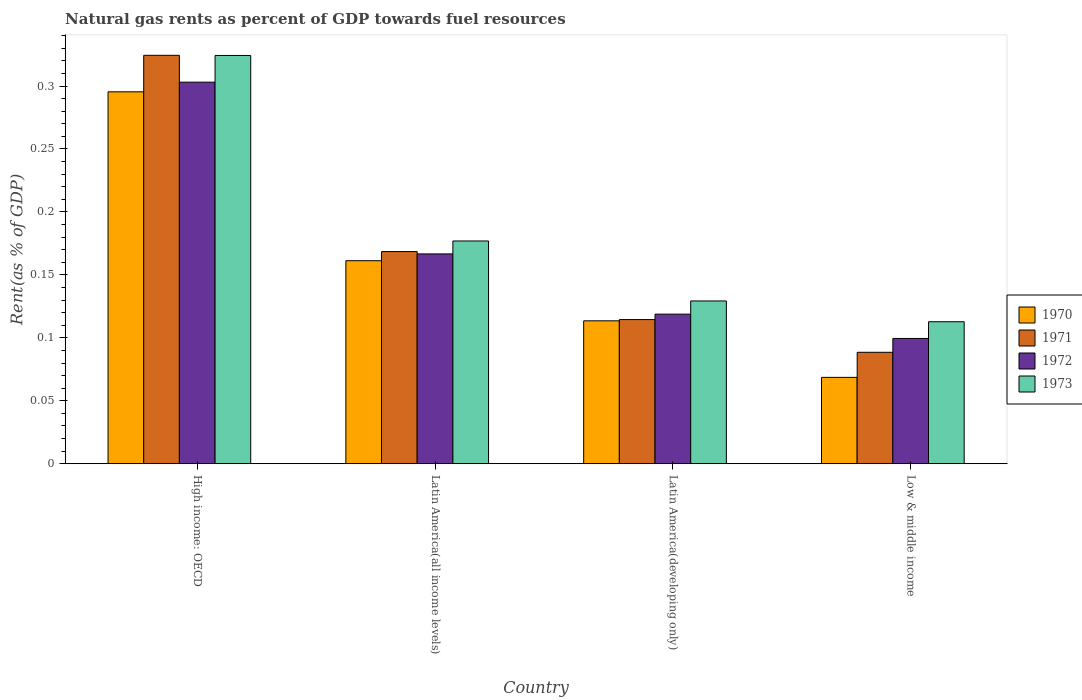Are the number of bars per tick equal to the number of legend labels?
Provide a short and direct response. Yes. How many bars are there on the 2nd tick from the right?
Provide a short and direct response. 4. What is the label of the 4th group of bars from the left?
Ensure brevity in your answer.  Low & middle income. What is the matural gas rent in 1972 in High income: OECD?
Make the answer very short. 0.3. Across all countries, what is the maximum matural gas rent in 1970?
Offer a terse response. 0.3. Across all countries, what is the minimum matural gas rent in 1970?
Provide a short and direct response. 0.07. In which country was the matural gas rent in 1971 maximum?
Give a very brief answer. High income: OECD. What is the total matural gas rent in 1972 in the graph?
Ensure brevity in your answer.  0.69. What is the difference between the matural gas rent in 1971 in Latin America(all income levels) and that in Low & middle income?
Your answer should be very brief. 0.08. What is the difference between the matural gas rent in 1973 in Latin America(developing only) and the matural gas rent in 1971 in High income: OECD?
Your answer should be compact. -0.2. What is the average matural gas rent in 1971 per country?
Provide a short and direct response. 0.17. What is the difference between the matural gas rent of/in 1970 and matural gas rent of/in 1973 in Low & middle income?
Give a very brief answer. -0.04. What is the ratio of the matural gas rent in 1973 in High income: OECD to that in Latin America(all income levels)?
Provide a short and direct response. 1.83. Is the matural gas rent in 1971 in High income: OECD less than that in Latin America(developing only)?
Ensure brevity in your answer.  No. Is the difference between the matural gas rent in 1970 in High income: OECD and Low & middle income greater than the difference between the matural gas rent in 1973 in High income: OECD and Low & middle income?
Your answer should be very brief. Yes. What is the difference between the highest and the second highest matural gas rent in 1970?
Offer a very short reply. 0.13. What is the difference between the highest and the lowest matural gas rent in 1971?
Offer a very short reply. 0.24. In how many countries, is the matural gas rent in 1973 greater than the average matural gas rent in 1973 taken over all countries?
Offer a terse response. 1. Is it the case that in every country, the sum of the matural gas rent in 1971 and matural gas rent in 1972 is greater than the sum of matural gas rent in 1973 and matural gas rent in 1970?
Offer a very short reply. No. Is it the case that in every country, the sum of the matural gas rent in 1973 and matural gas rent in 1971 is greater than the matural gas rent in 1972?
Your answer should be compact. Yes. What is the difference between two consecutive major ticks on the Y-axis?
Your answer should be compact. 0.05. Are the values on the major ticks of Y-axis written in scientific E-notation?
Give a very brief answer. No. Does the graph contain grids?
Keep it short and to the point. No. What is the title of the graph?
Offer a very short reply. Natural gas rents as percent of GDP towards fuel resources. Does "1977" appear as one of the legend labels in the graph?
Your answer should be very brief. No. What is the label or title of the X-axis?
Offer a very short reply. Country. What is the label or title of the Y-axis?
Offer a terse response. Rent(as % of GDP). What is the Rent(as % of GDP) of 1970 in High income: OECD?
Keep it short and to the point. 0.3. What is the Rent(as % of GDP) of 1971 in High income: OECD?
Provide a succinct answer. 0.32. What is the Rent(as % of GDP) in 1972 in High income: OECD?
Ensure brevity in your answer.  0.3. What is the Rent(as % of GDP) in 1973 in High income: OECD?
Your response must be concise. 0.32. What is the Rent(as % of GDP) of 1970 in Latin America(all income levels)?
Offer a terse response. 0.16. What is the Rent(as % of GDP) of 1971 in Latin America(all income levels)?
Your answer should be compact. 0.17. What is the Rent(as % of GDP) of 1972 in Latin America(all income levels)?
Your answer should be compact. 0.17. What is the Rent(as % of GDP) of 1973 in Latin America(all income levels)?
Offer a very short reply. 0.18. What is the Rent(as % of GDP) of 1970 in Latin America(developing only)?
Keep it short and to the point. 0.11. What is the Rent(as % of GDP) in 1971 in Latin America(developing only)?
Offer a terse response. 0.11. What is the Rent(as % of GDP) of 1972 in Latin America(developing only)?
Your answer should be compact. 0.12. What is the Rent(as % of GDP) of 1973 in Latin America(developing only)?
Keep it short and to the point. 0.13. What is the Rent(as % of GDP) in 1970 in Low & middle income?
Keep it short and to the point. 0.07. What is the Rent(as % of GDP) of 1971 in Low & middle income?
Provide a succinct answer. 0.09. What is the Rent(as % of GDP) in 1972 in Low & middle income?
Offer a very short reply. 0.1. What is the Rent(as % of GDP) in 1973 in Low & middle income?
Offer a terse response. 0.11. Across all countries, what is the maximum Rent(as % of GDP) of 1970?
Give a very brief answer. 0.3. Across all countries, what is the maximum Rent(as % of GDP) of 1971?
Your answer should be compact. 0.32. Across all countries, what is the maximum Rent(as % of GDP) in 1972?
Offer a very short reply. 0.3. Across all countries, what is the maximum Rent(as % of GDP) in 1973?
Offer a very short reply. 0.32. Across all countries, what is the minimum Rent(as % of GDP) of 1970?
Keep it short and to the point. 0.07. Across all countries, what is the minimum Rent(as % of GDP) in 1971?
Offer a very short reply. 0.09. Across all countries, what is the minimum Rent(as % of GDP) in 1972?
Your response must be concise. 0.1. Across all countries, what is the minimum Rent(as % of GDP) in 1973?
Provide a succinct answer. 0.11. What is the total Rent(as % of GDP) in 1970 in the graph?
Provide a succinct answer. 0.64. What is the total Rent(as % of GDP) of 1971 in the graph?
Provide a short and direct response. 0.7. What is the total Rent(as % of GDP) of 1972 in the graph?
Give a very brief answer. 0.69. What is the total Rent(as % of GDP) of 1973 in the graph?
Your answer should be very brief. 0.74. What is the difference between the Rent(as % of GDP) of 1970 in High income: OECD and that in Latin America(all income levels)?
Your response must be concise. 0.13. What is the difference between the Rent(as % of GDP) in 1971 in High income: OECD and that in Latin America(all income levels)?
Make the answer very short. 0.16. What is the difference between the Rent(as % of GDP) in 1972 in High income: OECD and that in Latin America(all income levels)?
Your answer should be compact. 0.14. What is the difference between the Rent(as % of GDP) of 1973 in High income: OECD and that in Latin America(all income levels)?
Offer a terse response. 0.15. What is the difference between the Rent(as % of GDP) of 1970 in High income: OECD and that in Latin America(developing only)?
Make the answer very short. 0.18. What is the difference between the Rent(as % of GDP) in 1971 in High income: OECD and that in Latin America(developing only)?
Your answer should be very brief. 0.21. What is the difference between the Rent(as % of GDP) in 1972 in High income: OECD and that in Latin America(developing only)?
Offer a very short reply. 0.18. What is the difference between the Rent(as % of GDP) of 1973 in High income: OECD and that in Latin America(developing only)?
Your answer should be compact. 0.2. What is the difference between the Rent(as % of GDP) in 1970 in High income: OECD and that in Low & middle income?
Keep it short and to the point. 0.23. What is the difference between the Rent(as % of GDP) of 1971 in High income: OECD and that in Low & middle income?
Ensure brevity in your answer.  0.24. What is the difference between the Rent(as % of GDP) in 1972 in High income: OECD and that in Low & middle income?
Your response must be concise. 0.2. What is the difference between the Rent(as % of GDP) in 1973 in High income: OECD and that in Low & middle income?
Your answer should be compact. 0.21. What is the difference between the Rent(as % of GDP) of 1970 in Latin America(all income levels) and that in Latin America(developing only)?
Provide a succinct answer. 0.05. What is the difference between the Rent(as % of GDP) in 1971 in Latin America(all income levels) and that in Latin America(developing only)?
Your response must be concise. 0.05. What is the difference between the Rent(as % of GDP) in 1972 in Latin America(all income levels) and that in Latin America(developing only)?
Offer a very short reply. 0.05. What is the difference between the Rent(as % of GDP) in 1973 in Latin America(all income levels) and that in Latin America(developing only)?
Your response must be concise. 0.05. What is the difference between the Rent(as % of GDP) in 1970 in Latin America(all income levels) and that in Low & middle income?
Provide a short and direct response. 0.09. What is the difference between the Rent(as % of GDP) of 1971 in Latin America(all income levels) and that in Low & middle income?
Keep it short and to the point. 0.08. What is the difference between the Rent(as % of GDP) in 1972 in Latin America(all income levels) and that in Low & middle income?
Your response must be concise. 0.07. What is the difference between the Rent(as % of GDP) of 1973 in Latin America(all income levels) and that in Low & middle income?
Make the answer very short. 0.06. What is the difference between the Rent(as % of GDP) in 1970 in Latin America(developing only) and that in Low & middle income?
Ensure brevity in your answer.  0.04. What is the difference between the Rent(as % of GDP) in 1971 in Latin America(developing only) and that in Low & middle income?
Give a very brief answer. 0.03. What is the difference between the Rent(as % of GDP) in 1972 in Latin America(developing only) and that in Low & middle income?
Give a very brief answer. 0.02. What is the difference between the Rent(as % of GDP) in 1973 in Latin America(developing only) and that in Low & middle income?
Offer a terse response. 0.02. What is the difference between the Rent(as % of GDP) in 1970 in High income: OECD and the Rent(as % of GDP) in 1971 in Latin America(all income levels)?
Provide a succinct answer. 0.13. What is the difference between the Rent(as % of GDP) in 1970 in High income: OECD and the Rent(as % of GDP) in 1972 in Latin America(all income levels)?
Offer a terse response. 0.13. What is the difference between the Rent(as % of GDP) of 1970 in High income: OECD and the Rent(as % of GDP) of 1973 in Latin America(all income levels)?
Offer a terse response. 0.12. What is the difference between the Rent(as % of GDP) in 1971 in High income: OECD and the Rent(as % of GDP) in 1972 in Latin America(all income levels)?
Give a very brief answer. 0.16. What is the difference between the Rent(as % of GDP) of 1971 in High income: OECD and the Rent(as % of GDP) of 1973 in Latin America(all income levels)?
Offer a very short reply. 0.15. What is the difference between the Rent(as % of GDP) of 1972 in High income: OECD and the Rent(as % of GDP) of 1973 in Latin America(all income levels)?
Provide a succinct answer. 0.13. What is the difference between the Rent(as % of GDP) of 1970 in High income: OECD and the Rent(as % of GDP) of 1971 in Latin America(developing only)?
Ensure brevity in your answer.  0.18. What is the difference between the Rent(as % of GDP) of 1970 in High income: OECD and the Rent(as % of GDP) of 1972 in Latin America(developing only)?
Provide a succinct answer. 0.18. What is the difference between the Rent(as % of GDP) in 1970 in High income: OECD and the Rent(as % of GDP) in 1973 in Latin America(developing only)?
Your answer should be compact. 0.17. What is the difference between the Rent(as % of GDP) of 1971 in High income: OECD and the Rent(as % of GDP) of 1972 in Latin America(developing only)?
Keep it short and to the point. 0.21. What is the difference between the Rent(as % of GDP) in 1971 in High income: OECD and the Rent(as % of GDP) in 1973 in Latin America(developing only)?
Make the answer very short. 0.2. What is the difference between the Rent(as % of GDP) of 1972 in High income: OECD and the Rent(as % of GDP) of 1973 in Latin America(developing only)?
Ensure brevity in your answer.  0.17. What is the difference between the Rent(as % of GDP) in 1970 in High income: OECD and the Rent(as % of GDP) in 1971 in Low & middle income?
Give a very brief answer. 0.21. What is the difference between the Rent(as % of GDP) in 1970 in High income: OECD and the Rent(as % of GDP) in 1972 in Low & middle income?
Ensure brevity in your answer.  0.2. What is the difference between the Rent(as % of GDP) of 1970 in High income: OECD and the Rent(as % of GDP) of 1973 in Low & middle income?
Your answer should be very brief. 0.18. What is the difference between the Rent(as % of GDP) in 1971 in High income: OECD and the Rent(as % of GDP) in 1972 in Low & middle income?
Keep it short and to the point. 0.22. What is the difference between the Rent(as % of GDP) in 1971 in High income: OECD and the Rent(as % of GDP) in 1973 in Low & middle income?
Your answer should be very brief. 0.21. What is the difference between the Rent(as % of GDP) in 1972 in High income: OECD and the Rent(as % of GDP) in 1973 in Low & middle income?
Your answer should be very brief. 0.19. What is the difference between the Rent(as % of GDP) of 1970 in Latin America(all income levels) and the Rent(as % of GDP) of 1971 in Latin America(developing only)?
Ensure brevity in your answer.  0.05. What is the difference between the Rent(as % of GDP) of 1970 in Latin America(all income levels) and the Rent(as % of GDP) of 1972 in Latin America(developing only)?
Ensure brevity in your answer.  0.04. What is the difference between the Rent(as % of GDP) in 1970 in Latin America(all income levels) and the Rent(as % of GDP) in 1973 in Latin America(developing only)?
Ensure brevity in your answer.  0.03. What is the difference between the Rent(as % of GDP) in 1971 in Latin America(all income levels) and the Rent(as % of GDP) in 1972 in Latin America(developing only)?
Keep it short and to the point. 0.05. What is the difference between the Rent(as % of GDP) in 1971 in Latin America(all income levels) and the Rent(as % of GDP) in 1973 in Latin America(developing only)?
Your answer should be compact. 0.04. What is the difference between the Rent(as % of GDP) of 1972 in Latin America(all income levels) and the Rent(as % of GDP) of 1973 in Latin America(developing only)?
Offer a very short reply. 0.04. What is the difference between the Rent(as % of GDP) of 1970 in Latin America(all income levels) and the Rent(as % of GDP) of 1971 in Low & middle income?
Your answer should be very brief. 0.07. What is the difference between the Rent(as % of GDP) of 1970 in Latin America(all income levels) and the Rent(as % of GDP) of 1972 in Low & middle income?
Offer a very short reply. 0.06. What is the difference between the Rent(as % of GDP) of 1970 in Latin America(all income levels) and the Rent(as % of GDP) of 1973 in Low & middle income?
Offer a terse response. 0.05. What is the difference between the Rent(as % of GDP) in 1971 in Latin America(all income levels) and the Rent(as % of GDP) in 1972 in Low & middle income?
Offer a very short reply. 0.07. What is the difference between the Rent(as % of GDP) of 1971 in Latin America(all income levels) and the Rent(as % of GDP) of 1973 in Low & middle income?
Provide a succinct answer. 0.06. What is the difference between the Rent(as % of GDP) in 1972 in Latin America(all income levels) and the Rent(as % of GDP) in 1973 in Low & middle income?
Offer a terse response. 0.05. What is the difference between the Rent(as % of GDP) in 1970 in Latin America(developing only) and the Rent(as % of GDP) in 1971 in Low & middle income?
Offer a terse response. 0.03. What is the difference between the Rent(as % of GDP) in 1970 in Latin America(developing only) and the Rent(as % of GDP) in 1972 in Low & middle income?
Keep it short and to the point. 0.01. What is the difference between the Rent(as % of GDP) in 1970 in Latin America(developing only) and the Rent(as % of GDP) in 1973 in Low & middle income?
Provide a succinct answer. 0. What is the difference between the Rent(as % of GDP) in 1971 in Latin America(developing only) and the Rent(as % of GDP) in 1972 in Low & middle income?
Provide a short and direct response. 0.01. What is the difference between the Rent(as % of GDP) of 1971 in Latin America(developing only) and the Rent(as % of GDP) of 1973 in Low & middle income?
Offer a terse response. 0. What is the difference between the Rent(as % of GDP) of 1972 in Latin America(developing only) and the Rent(as % of GDP) of 1973 in Low & middle income?
Ensure brevity in your answer.  0.01. What is the average Rent(as % of GDP) in 1970 per country?
Make the answer very short. 0.16. What is the average Rent(as % of GDP) in 1971 per country?
Offer a terse response. 0.17. What is the average Rent(as % of GDP) of 1972 per country?
Make the answer very short. 0.17. What is the average Rent(as % of GDP) in 1973 per country?
Provide a succinct answer. 0.19. What is the difference between the Rent(as % of GDP) in 1970 and Rent(as % of GDP) in 1971 in High income: OECD?
Provide a short and direct response. -0.03. What is the difference between the Rent(as % of GDP) of 1970 and Rent(as % of GDP) of 1972 in High income: OECD?
Give a very brief answer. -0.01. What is the difference between the Rent(as % of GDP) in 1970 and Rent(as % of GDP) in 1973 in High income: OECD?
Provide a succinct answer. -0.03. What is the difference between the Rent(as % of GDP) in 1971 and Rent(as % of GDP) in 1972 in High income: OECD?
Provide a short and direct response. 0.02. What is the difference between the Rent(as % of GDP) of 1971 and Rent(as % of GDP) of 1973 in High income: OECD?
Your answer should be very brief. 0. What is the difference between the Rent(as % of GDP) in 1972 and Rent(as % of GDP) in 1973 in High income: OECD?
Offer a very short reply. -0.02. What is the difference between the Rent(as % of GDP) of 1970 and Rent(as % of GDP) of 1971 in Latin America(all income levels)?
Make the answer very short. -0.01. What is the difference between the Rent(as % of GDP) of 1970 and Rent(as % of GDP) of 1972 in Latin America(all income levels)?
Ensure brevity in your answer.  -0.01. What is the difference between the Rent(as % of GDP) of 1970 and Rent(as % of GDP) of 1973 in Latin America(all income levels)?
Offer a terse response. -0.02. What is the difference between the Rent(as % of GDP) of 1971 and Rent(as % of GDP) of 1972 in Latin America(all income levels)?
Provide a succinct answer. 0. What is the difference between the Rent(as % of GDP) of 1971 and Rent(as % of GDP) of 1973 in Latin America(all income levels)?
Give a very brief answer. -0.01. What is the difference between the Rent(as % of GDP) in 1972 and Rent(as % of GDP) in 1973 in Latin America(all income levels)?
Keep it short and to the point. -0.01. What is the difference between the Rent(as % of GDP) in 1970 and Rent(as % of GDP) in 1971 in Latin America(developing only)?
Offer a terse response. -0. What is the difference between the Rent(as % of GDP) in 1970 and Rent(as % of GDP) in 1972 in Latin America(developing only)?
Make the answer very short. -0.01. What is the difference between the Rent(as % of GDP) in 1970 and Rent(as % of GDP) in 1973 in Latin America(developing only)?
Give a very brief answer. -0.02. What is the difference between the Rent(as % of GDP) in 1971 and Rent(as % of GDP) in 1972 in Latin America(developing only)?
Give a very brief answer. -0. What is the difference between the Rent(as % of GDP) of 1971 and Rent(as % of GDP) of 1973 in Latin America(developing only)?
Give a very brief answer. -0.01. What is the difference between the Rent(as % of GDP) of 1972 and Rent(as % of GDP) of 1973 in Latin America(developing only)?
Make the answer very short. -0.01. What is the difference between the Rent(as % of GDP) in 1970 and Rent(as % of GDP) in 1971 in Low & middle income?
Provide a succinct answer. -0.02. What is the difference between the Rent(as % of GDP) in 1970 and Rent(as % of GDP) in 1972 in Low & middle income?
Your answer should be very brief. -0.03. What is the difference between the Rent(as % of GDP) of 1970 and Rent(as % of GDP) of 1973 in Low & middle income?
Ensure brevity in your answer.  -0.04. What is the difference between the Rent(as % of GDP) of 1971 and Rent(as % of GDP) of 1972 in Low & middle income?
Your response must be concise. -0.01. What is the difference between the Rent(as % of GDP) of 1971 and Rent(as % of GDP) of 1973 in Low & middle income?
Give a very brief answer. -0.02. What is the difference between the Rent(as % of GDP) in 1972 and Rent(as % of GDP) in 1973 in Low & middle income?
Provide a short and direct response. -0.01. What is the ratio of the Rent(as % of GDP) of 1970 in High income: OECD to that in Latin America(all income levels)?
Provide a short and direct response. 1.83. What is the ratio of the Rent(as % of GDP) in 1971 in High income: OECD to that in Latin America(all income levels)?
Give a very brief answer. 1.93. What is the ratio of the Rent(as % of GDP) of 1972 in High income: OECD to that in Latin America(all income levels)?
Offer a terse response. 1.82. What is the ratio of the Rent(as % of GDP) of 1973 in High income: OECD to that in Latin America(all income levels)?
Ensure brevity in your answer.  1.83. What is the ratio of the Rent(as % of GDP) in 1970 in High income: OECD to that in Latin America(developing only)?
Your answer should be compact. 2.6. What is the ratio of the Rent(as % of GDP) in 1971 in High income: OECD to that in Latin America(developing only)?
Ensure brevity in your answer.  2.83. What is the ratio of the Rent(as % of GDP) in 1972 in High income: OECD to that in Latin America(developing only)?
Provide a succinct answer. 2.55. What is the ratio of the Rent(as % of GDP) in 1973 in High income: OECD to that in Latin America(developing only)?
Ensure brevity in your answer.  2.51. What is the ratio of the Rent(as % of GDP) of 1970 in High income: OECD to that in Low & middle income?
Ensure brevity in your answer.  4.31. What is the ratio of the Rent(as % of GDP) of 1971 in High income: OECD to that in Low & middle income?
Your response must be concise. 3.66. What is the ratio of the Rent(as % of GDP) in 1972 in High income: OECD to that in Low & middle income?
Provide a short and direct response. 3.05. What is the ratio of the Rent(as % of GDP) of 1973 in High income: OECD to that in Low & middle income?
Your answer should be very brief. 2.88. What is the ratio of the Rent(as % of GDP) of 1970 in Latin America(all income levels) to that in Latin America(developing only)?
Provide a short and direct response. 1.42. What is the ratio of the Rent(as % of GDP) of 1971 in Latin America(all income levels) to that in Latin America(developing only)?
Ensure brevity in your answer.  1.47. What is the ratio of the Rent(as % of GDP) of 1972 in Latin America(all income levels) to that in Latin America(developing only)?
Provide a short and direct response. 1.4. What is the ratio of the Rent(as % of GDP) of 1973 in Latin America(all income levels) to that in Latin America(developing only)?
Offer a very short reply. 1.37. What is the ratio of the Rent(as % of GDP) of 1970 in Latin America(all income levels) to that in Low & middle income?
Offer a very short reply. 2.35. What is the ratio of the Rent(as % of GDP) in 1971 in Latin America(all income levels) to that in Low & middle income?
Your answer should be very brief. 1.9. What is the ratio of the Rent(as % of GDP) of 1972 in Latin America(all income levels) to that in Low & middle income?
Your answer should be compact. 1.67. What is the ratio of the Rent(as % of GDP) of 1973 in Latin America(all income levels) to that in Low & middle income?
Provide a short and direct response. 1.57. What is the ratio of the Rent(as % of GDP) in 1970 in Latin America(developing only) to that in Low & middle income?
Your answer should be very brief. 1.65. What is the ratio of the Rent(as % of GDP) in 1971 in Latin America(developing only) to that in Low & middle income?
Provide a short and direct response. 1.29. What is the ratio of the Rent(as % of GDP) in 1972 in Latin America(developing only) to that in Low & middle income?
Offer a terse response. 1.19. What is the ratio of the Rent(as % of GDP) in 1973 in Latin America(developing only) to that in Low & middle income?
Your answer should be compact. 1.15. What is the difference between the highest and the second highest Rent(as % of GDP) in 1970?
Make the answer very short. 0.13. What is the difference between the highest and the second highest Rent(as % of GDP) of 1971?
Provide a succinct answer. 0.16. What is the difference between the highest and the second highest Rent(as % of GDP) in 1972?
Your answer should be very brief. 0.14. What is the difference between the highest and the second highest Rent(as % of GDP) of 1973?
Your answer should be compact. 0.15. What is the difference between the highest and the lowest Rent(as % of GDP) of 1970?
Keep it short and to the point. 0.23. What is the difference between the highest and the lowest Rent(as % of GDP) in 1971?
Offer a terse response. 0.24. What is the difference between the highest and the lowest Rent(as % of GDP) in 1972?
Provide a succinct answer. 0.2. What is the difference between the highest and the lowest Rent(as % of GDP) in 1973?
Offer a terse response. 0.21. 